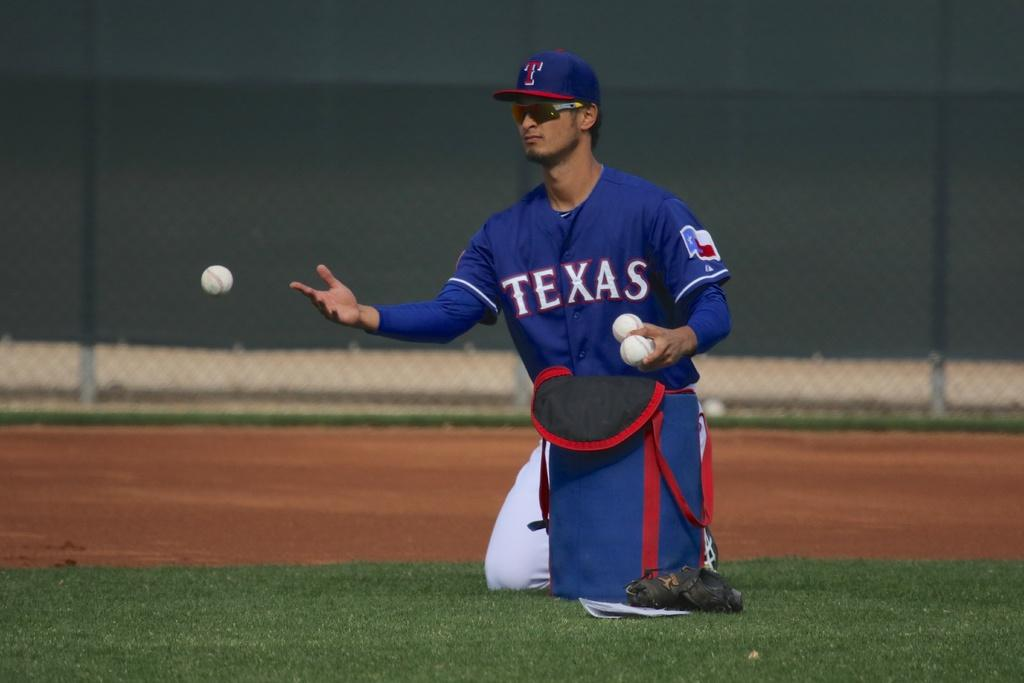<image>
Provide a brief description of the given image. A player for theTexas Rangers sitting on the ground 